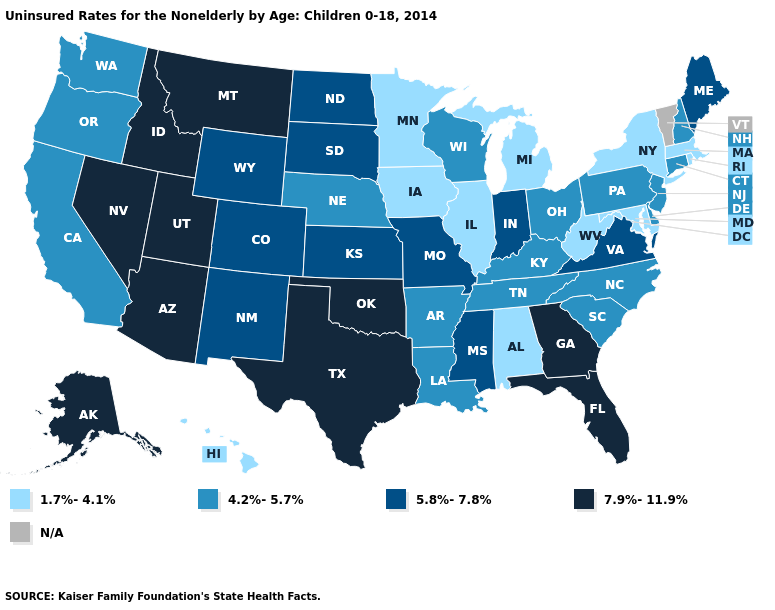What is the value of Arkansas?
Answer briefly. 4.2%-5.7%. Is the legend a continuous bar?
Keep it brief. No. What is the highest value in states that border Iowa?
Keep it brief. 5.8%-7.8%. Does the map have missing data?
Keep it brief. Yes. Name the states that have a value in the range 1.7%-4.1%?
Write a very short answer. Alabama, Hawaii, Illinois, Iowa, Maryland, Massachusetts, Michigan, Minnesota, New York, Rhode Island, West Virginia. What is the value of North Dakota?
Write a very short answer. 5.8%-7.8%. What is the lowest value in the West?
Short answer required. 1.7%-4.1%. What is the highest value in states that border Utah?
Keep it brief. 7.9%-11.9%. Among the states that border North Carolina , does Tennessee have the lowest value?
Concise answer only. Yes. Which states hav the highest value in the South?
Give a very brief answer. Florida, Georgia, Oklahoma, Texas. What is the highest value in the USA?
Short answer required. 7.9%-11.9%. Among the states that border North Dakota , which have the highest value?
Give a very brief answer. Montana. Does Kansas have the highest value in the MidWest?
Quick response, please. Yes. Name the states that have a value in the range N/A?
Short answer required. Vermont. Name the states that have a value in the range 5.8%-7.8%?
Keep it brief. Colorado, Indiana, Kansas, Maine, Mississippi, Missouri, New Mexico, North Dakota, South Dakota, Virginia, Wyoming. 